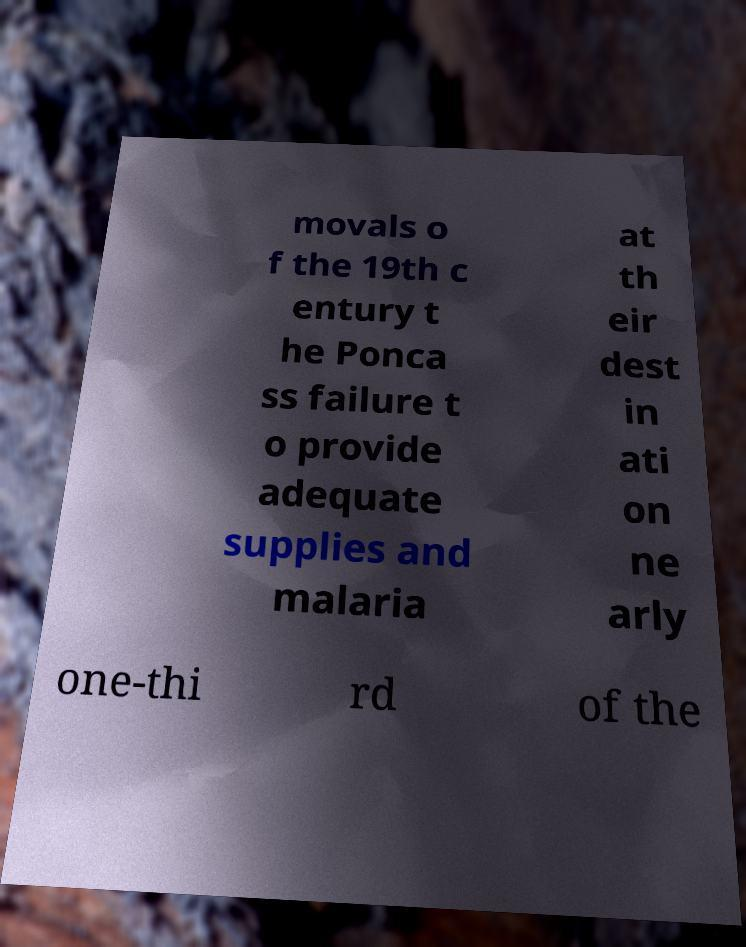Can you read and provide the text displayed in the image?This photo seems to have some interesting text. Can you extract and type it out for me? movals o f the 19th c entury t he Ponca ss failure t o provide adequate supplies and malaria at th eir dest in ati on ne arly one-thi rd of the 